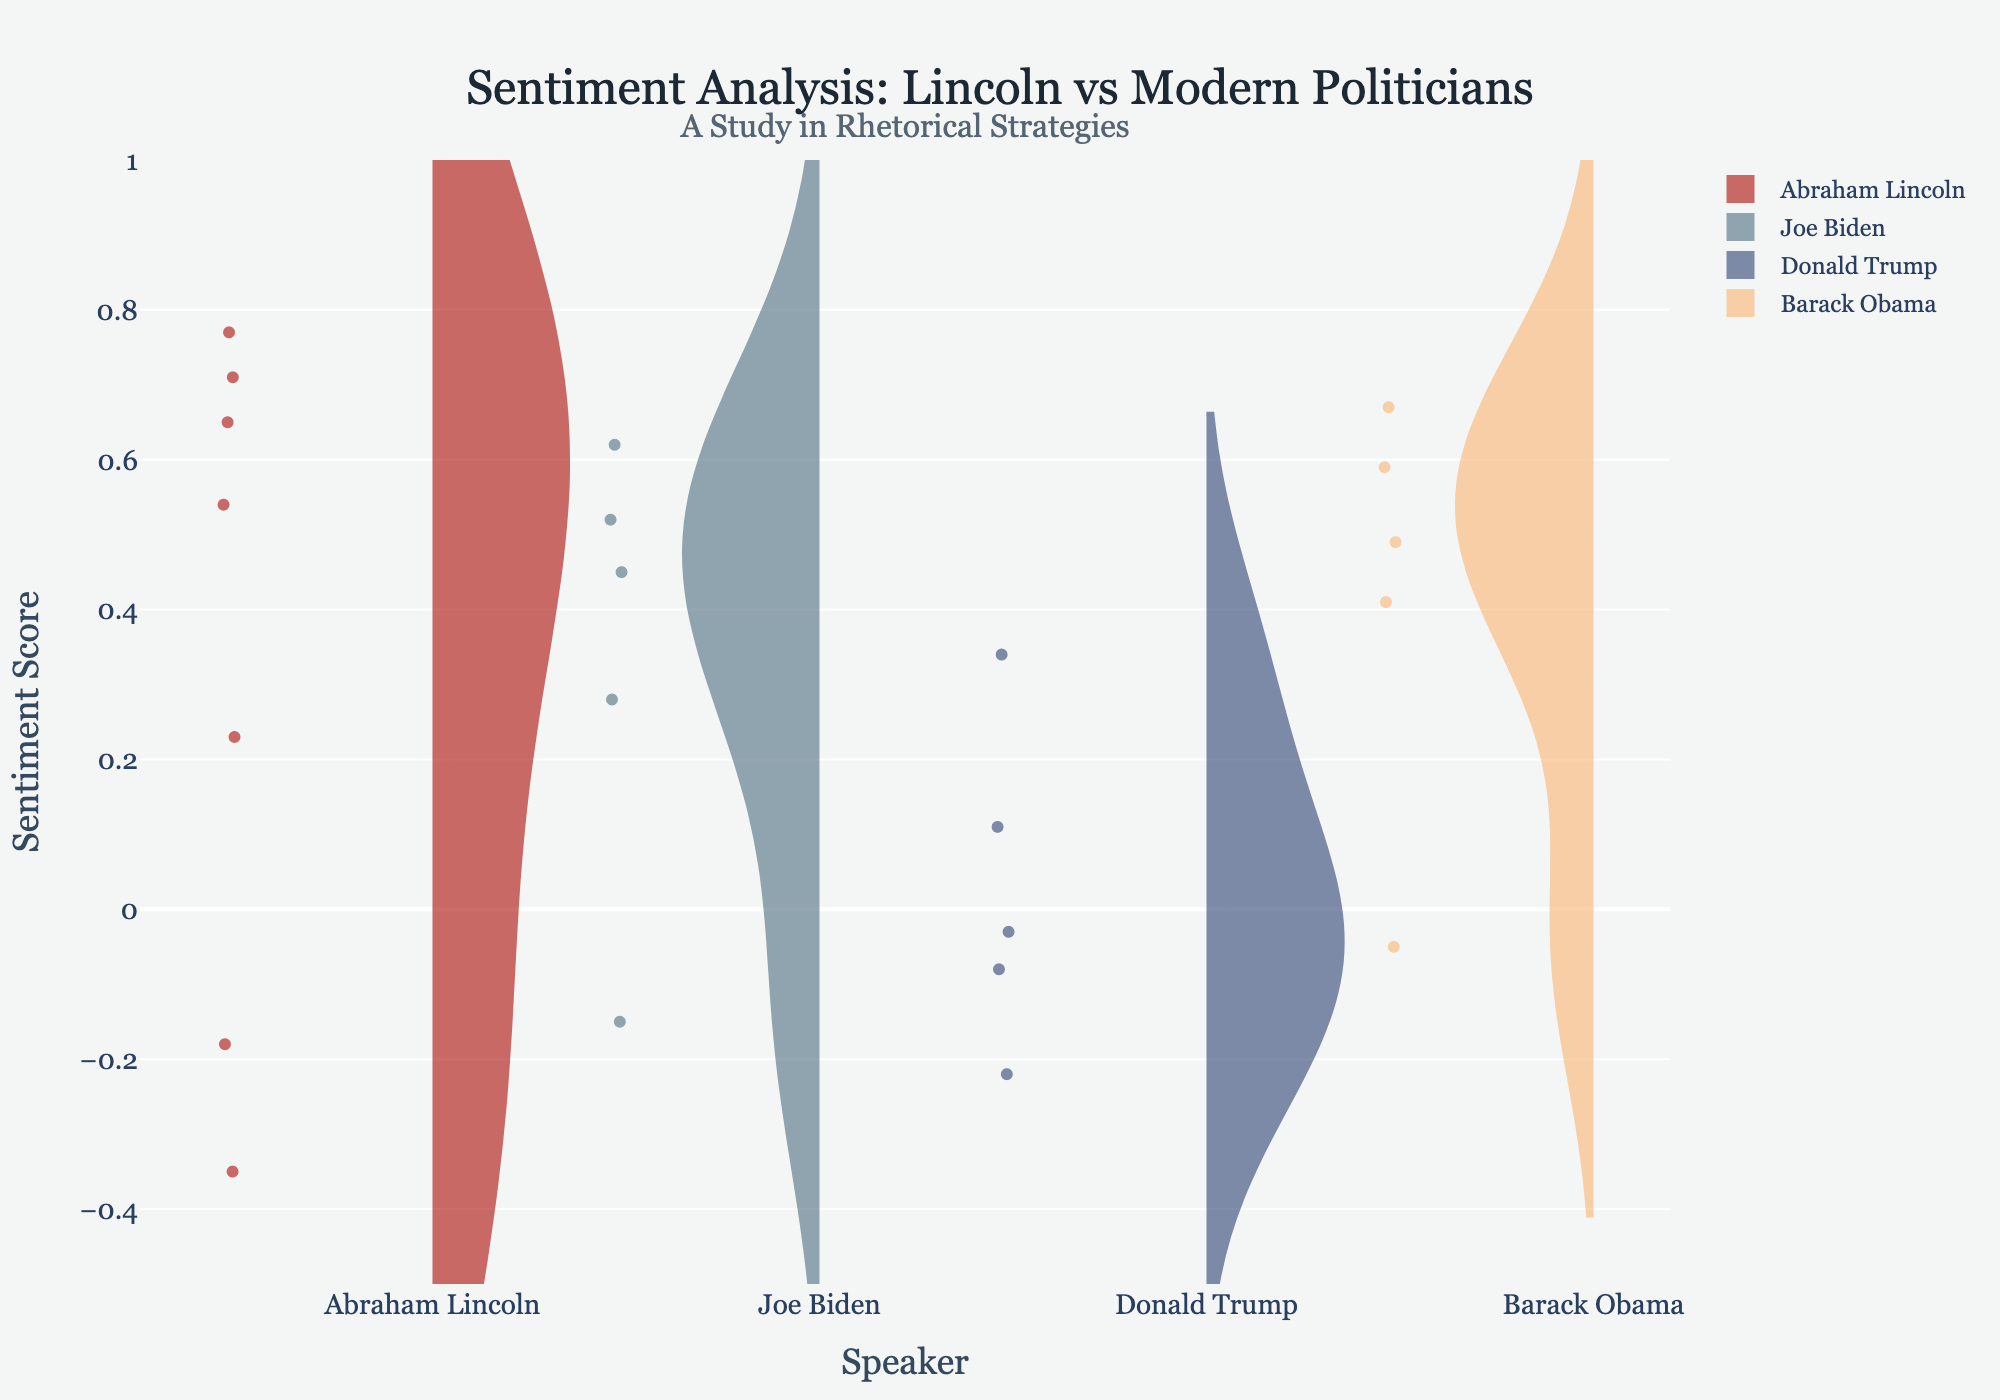What's the title of the plot? The title is usually displayed at the top center of the plot. Here, it reads "Sentiment Analysis: Lincoln vs Modern Politicians."
Answer: Sentiment Analysis: Lincoln vs Modern Politicians What does the y-axis represent on this plot? The y-axis title, which is displayed vertically on the left of the plot, indicates that it represents the "Sentiment Score."
Answer: Sentiment Score Which speaker has the highest mean sentiment score? The violin with the highest central tendency (mean line) needs to be identified. Abraham Lincoln's violins have the highest average score.
Answer: Abraham Lincoln Which speech by Abraham Lincoln has the most negative sentiment score? By comparing the data points for Abraham Lincoln’s speeches, the "Speech on the Dred Scott Decision" has the most negative sentiment score.
Answer: Speech on the Dred Scott Decision Which president has the speech with the highest recorded sentiment score? Among the sentiments recorded, the speech "The Gettysburg Address" by Abraham Lincoln has the highest sentiment score (0.77).
Answer: Abraham Lincoln How do the overall sentiment distributions of Abraham Lincoln and Joe Biden compare? Compare the shapes and spread of the violins for Abraham Lincoln and Joe Biden to observe how their distributions overlap and differ in sentiment scores. Lincoln’s speeches generally show a higher sentiment with wider positive distribution.
Answer: Lincoln has higher sentiment scores overall How many speeches of each speaker are included in the plot? Count the data points associated with each speaker. For Lincoln, there are 6; for Biden, 5; for Trump, 5; for Obama, 5.
Answer: Lincoln: 6, Biden: 5, Trump: 5, Obama: 5 What is the sentiment range of Donald Trump's speeches? Identify the minimum and maximum sentiment scores of Trump’s speeches to determine the range. The sentiments for Trump range from -0.22 to 0.34.
Answer: -0.22 to 0.34 Which modern president has the most speeches with negative sentiments? Compare the number of negative sentiment speeches for Biden, Trump, and Obama. Trump has the most negative speeches.
Answer: Donald Trump 